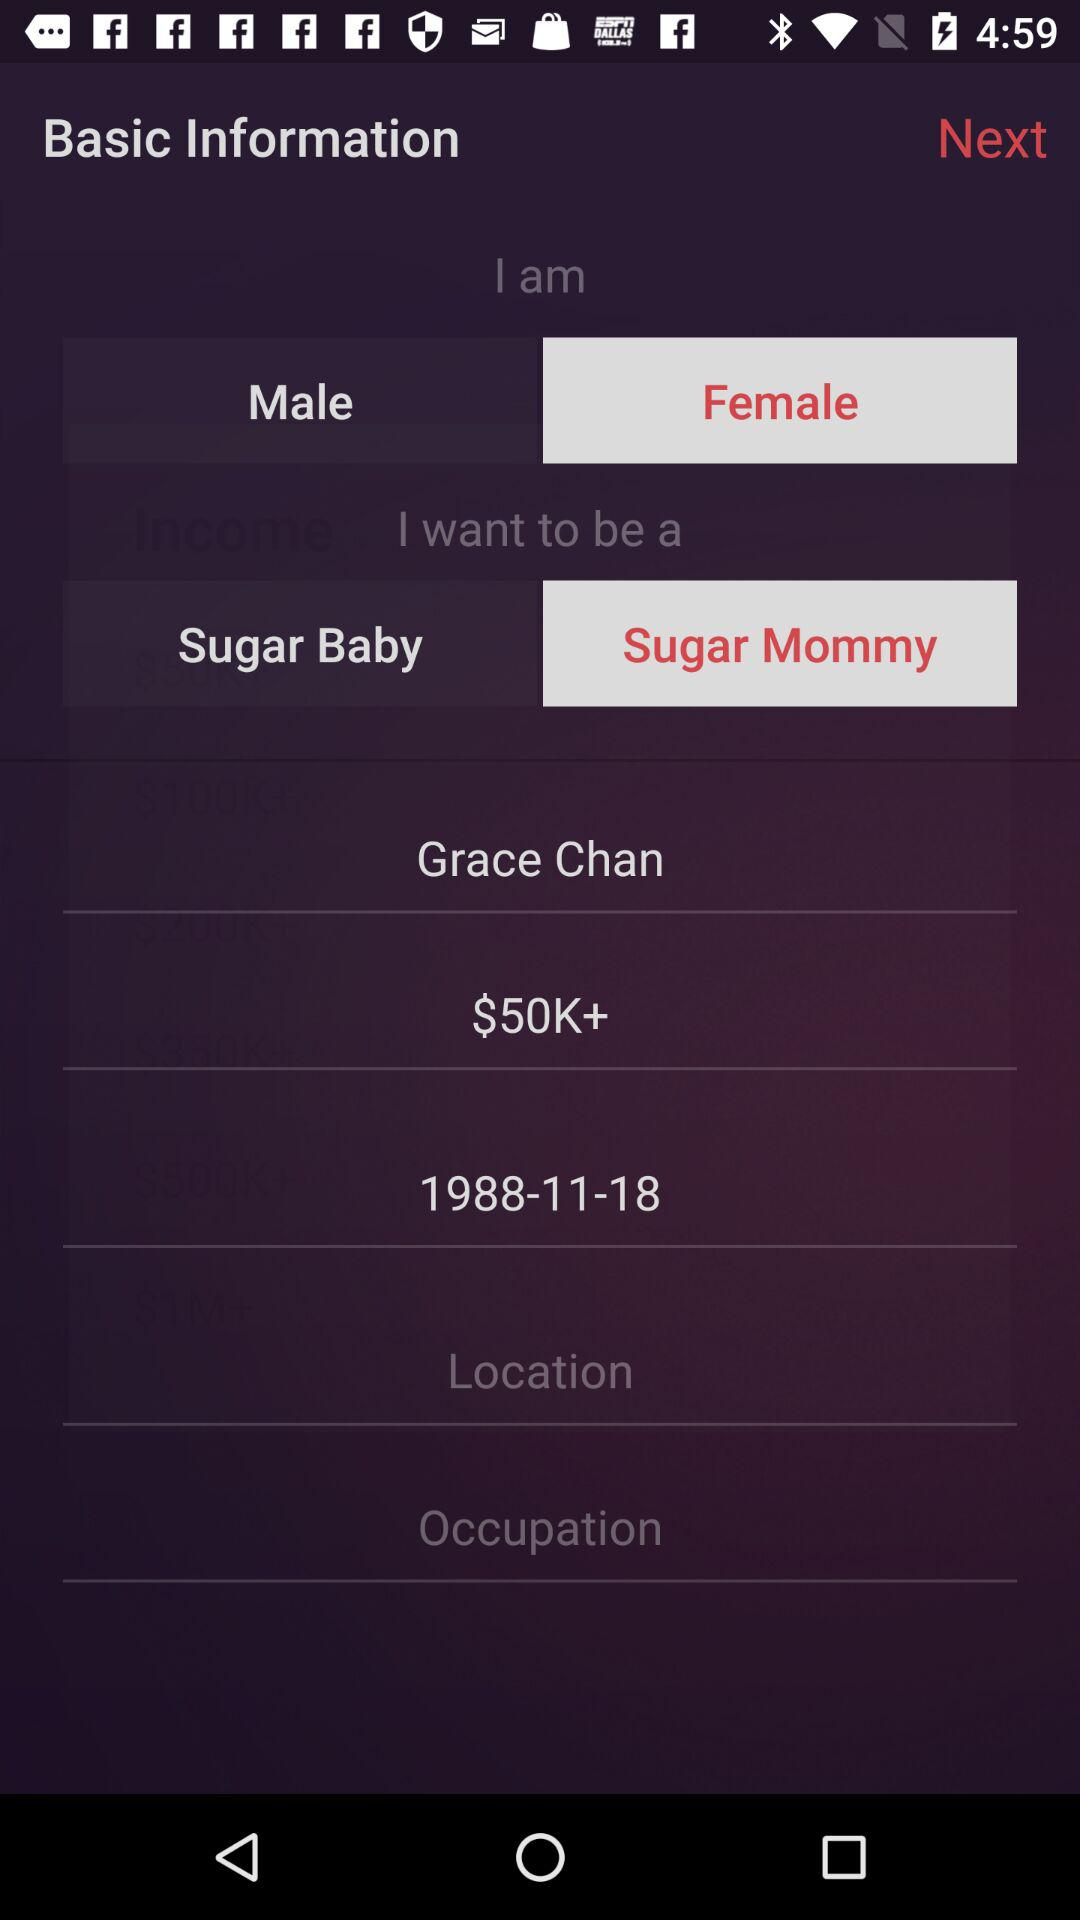What is the location?
When the provided information is insufficient, respond with <no answer>. <no answer> 